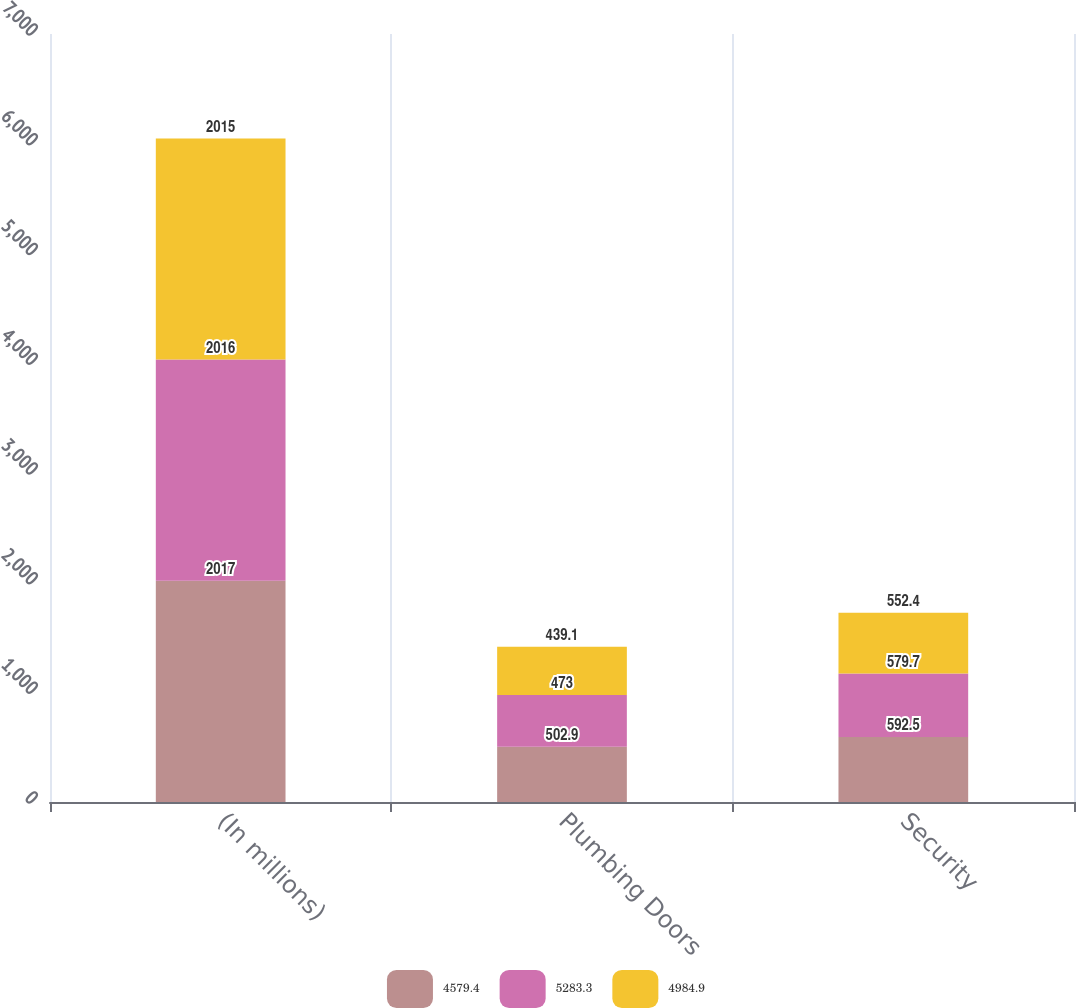<chart> <loc_0><loc_0><loc_500><loc_500><stacked_bar_chart><ecel><fcel>(In millions)<fcel>Plumbing Doors<fcel>Security<nl><fcel>4579.4<fcel>2017<fcel>502.9<fcel>592.5<nl><fcel>5283.3<fcel>2016<fcel>473<fcel>579.7<nl><fcel>4984.9<fcel>2015<fcel>439.1<fcel>552.4<nl></chart> 